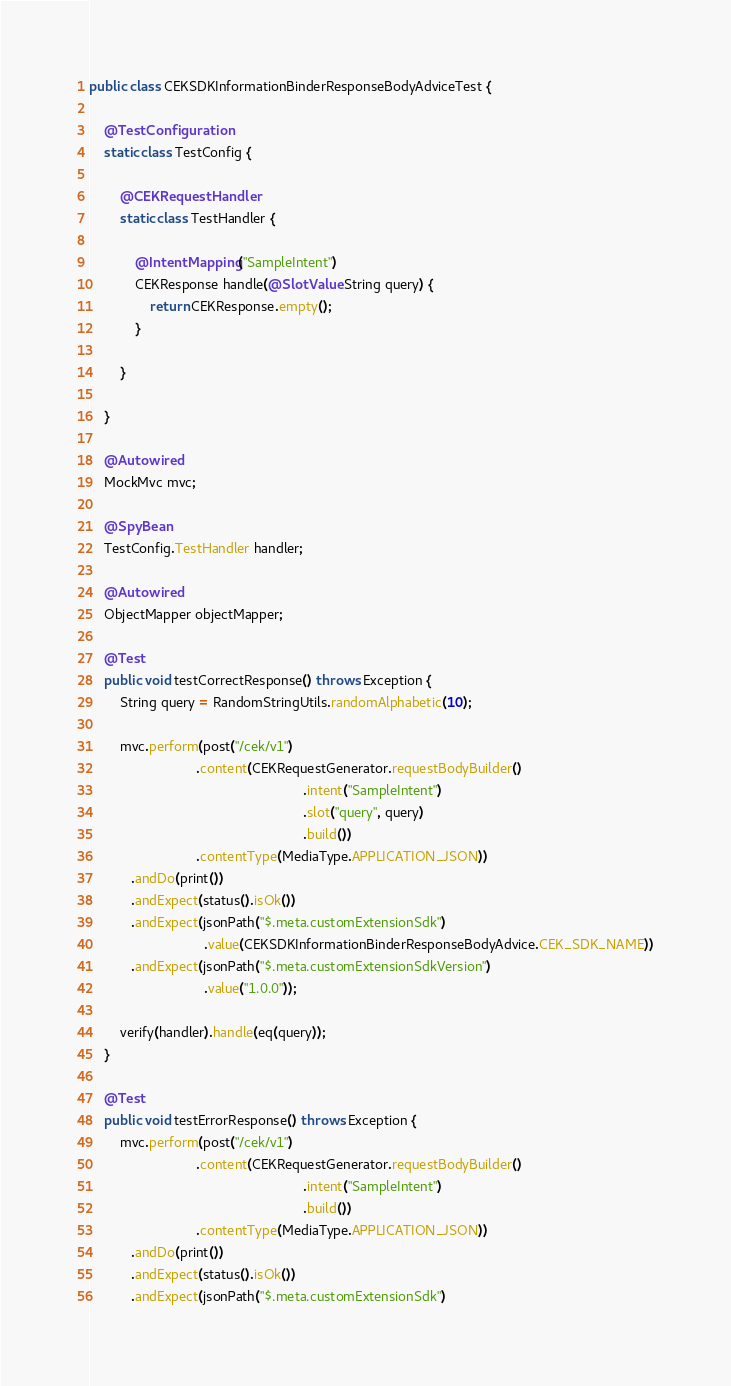Convert code to text. <code><loc_0><loc_0><loc_500><loc_500><_Java_>public class CEKSDKInformationBinderResponseBodyAdviceTest {

    @TestConfiguration
    static class TestConfig {

        @CEKRequestHandler
        static class TestHandler {

            @IntentMapping("SampleIntent")
            CEKResponse handle(@SlotValue String query) {
                return CEKResponse.empty();
            }

        }

    }

    @Autowired
    MockMvc mvc;

    @SpyBean
    TestConfig.TestHandler handler;

    @Autowired
    ObjectMapper objectMapper;

    @Test
    public void testCorrectResponse() throws Exception {
        String query = RandomStringUtils.randomAlphabetic(10);

        mvc.perform(post("/cek/v1")
                            .content(CEKRequestGenerator.requestBodyBuilder()
                                                        .intent("SampleIntent")
                                                        .slot("query", query)
                                                        .build())
                            .contentType(MediaType.APPLICATION_JSON))
           .andDo(print())
           .andExpect(status().isOk())
           .andExpect(jsonPath("$.meta.customExtensionSdk")
                              .value(CEKSDKInformationBinderResponseBodyAdvice.CEK_SDK_NAME))
           .andExpect(jsonPath("$.meta.customExtensionSdkVersion")
                              .value("1.0.0"));

        verify(handler).handle(eq(query));
    }

    @Test
    public void testErrorResponse() throws Exception {
        mvc.perform(post("/cek/v1")
                            .content(CEKRequestGenerator.requestBodyBuilder()
                                                        .intent("SampleIntent")
                                                        .build())
                            .contentType(MediaType.APPLICATION_JSON))
           .andDo(print())
           .andExpect(status().isOk())
           .andExpect(jsonPath("$.meta.customExtensionSdk")</code> 